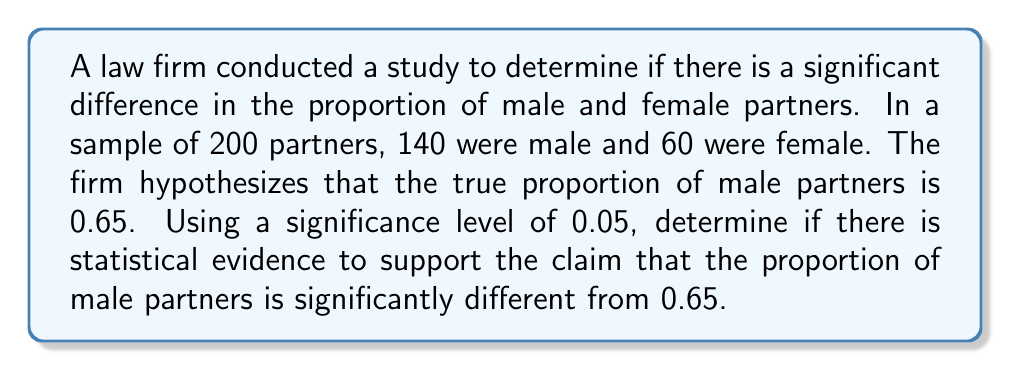Can you solve this math problem? To determine statistical significance, we'll use a two-tailed z-test for a proportion.

Step 1: State the null and alternative hypotheses
$H_0: p = 0.65$ (null hypothesis)
$H_a: p \neq 0.65$ (alternative hypothesis)

Step 2: Calculate the sample proportion
$\hat{p} = \frac{140}{200} = 0.70$

Step 3: Calculate the standard error
$SE = \sqrt{\frac{p_0(1-p_0)}{n}} = \sqrt{\frac{0.65(1-0.65)}{200}} = 0.0337$

Step 4: Calculate the z-score
$z = \frac{\hat{p} - p_0}{SE} = \frac{0.70 - 0.65}{0.0337} = 1.4836$

Step 5: Determine the critical value
For a two-tailed test with α = 0.05, the critical z-value is ±1.96.

Step 6: Compare the calculated z-score to the critical value
$|1.4836| < 1.96$

Step 7: Calculate the p-value
$p-value = 2 \times P(Z > 1.4836) = 2 \times 0.0689 = 0.1378$

Since the p-value (0.1378) is greater than the significance level (0.05), we fail to reject the null hypothesis.
Answer: Fail to reject the null hypothesis; no significant difference from 0.65 (p = 0.1378 > 0.05). 